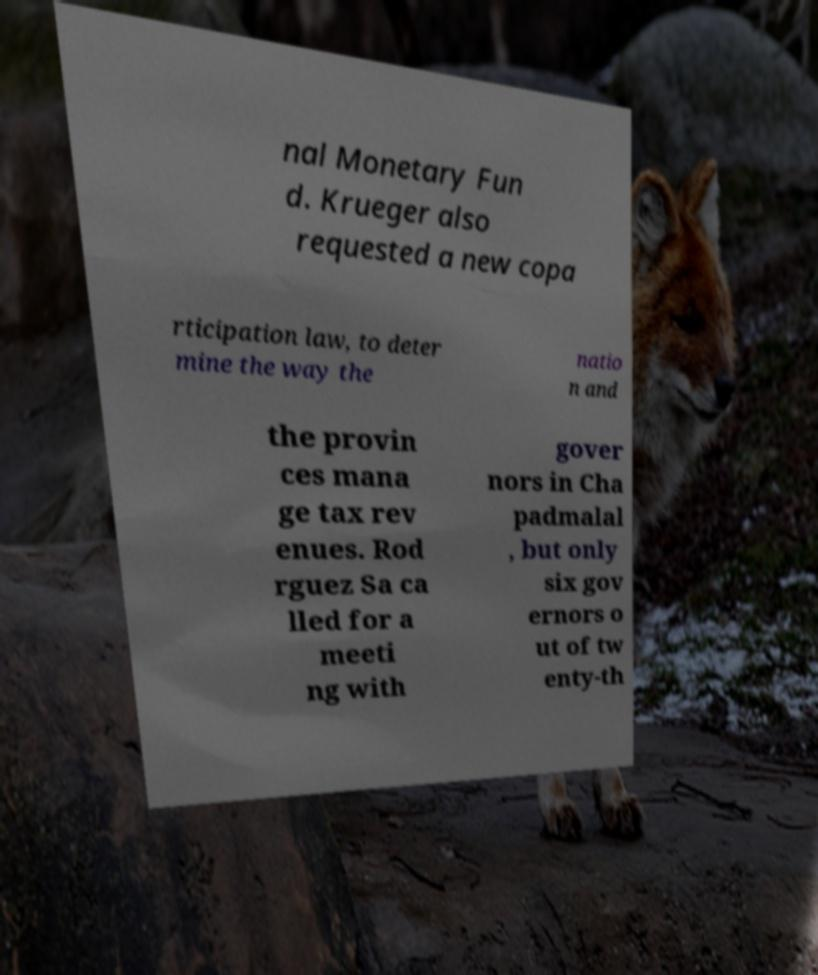There's text embedded in this image that I need extracted. Can you transcribe it verbatim? nal Monetary Fun d. Krueger also requested a new copa rticipation law, to deter mine the way the natio n and the provin ces mana ge tax rev enues. Rod rguez Sa ca lled for a meeti ng with gover nors in Cha padmalal , but only six gov ernors o ut of tw enty-th 